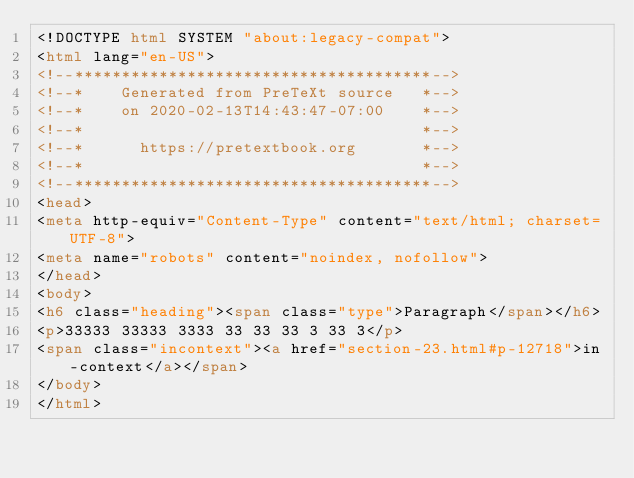<code> <loc_0><loc_0><loc_500><loc_500><_HTML_><!DOCTYPE html SYSTEM "about:legacy-compat">
<html lang="en-US">
<!--**************************************-->
<!--*    Generated from PreTeXt source   *-->
<!--*    on 2020-02-13T14:43:47-07:00    *-->
<!--*                                    *-->
<!--*      https://pretextbook.org       *-->
<!--*                                    *-->
<!--**************************************-->
<head>
<meta http-equiv="Content-Type" content="text/html; charset=UTF-8">
<meta name="robots" content="noindex, nofollow">
</head>
<body>
<h6 class="heading"><span class="type">Paragraph</span></h6>
<p>33333 33333 3333 33 33 33 3 33 3</p>
<span class="incontext"><a href="section-23.html#p-12718">in-context</a></span>
</body>
</html>
</code> 